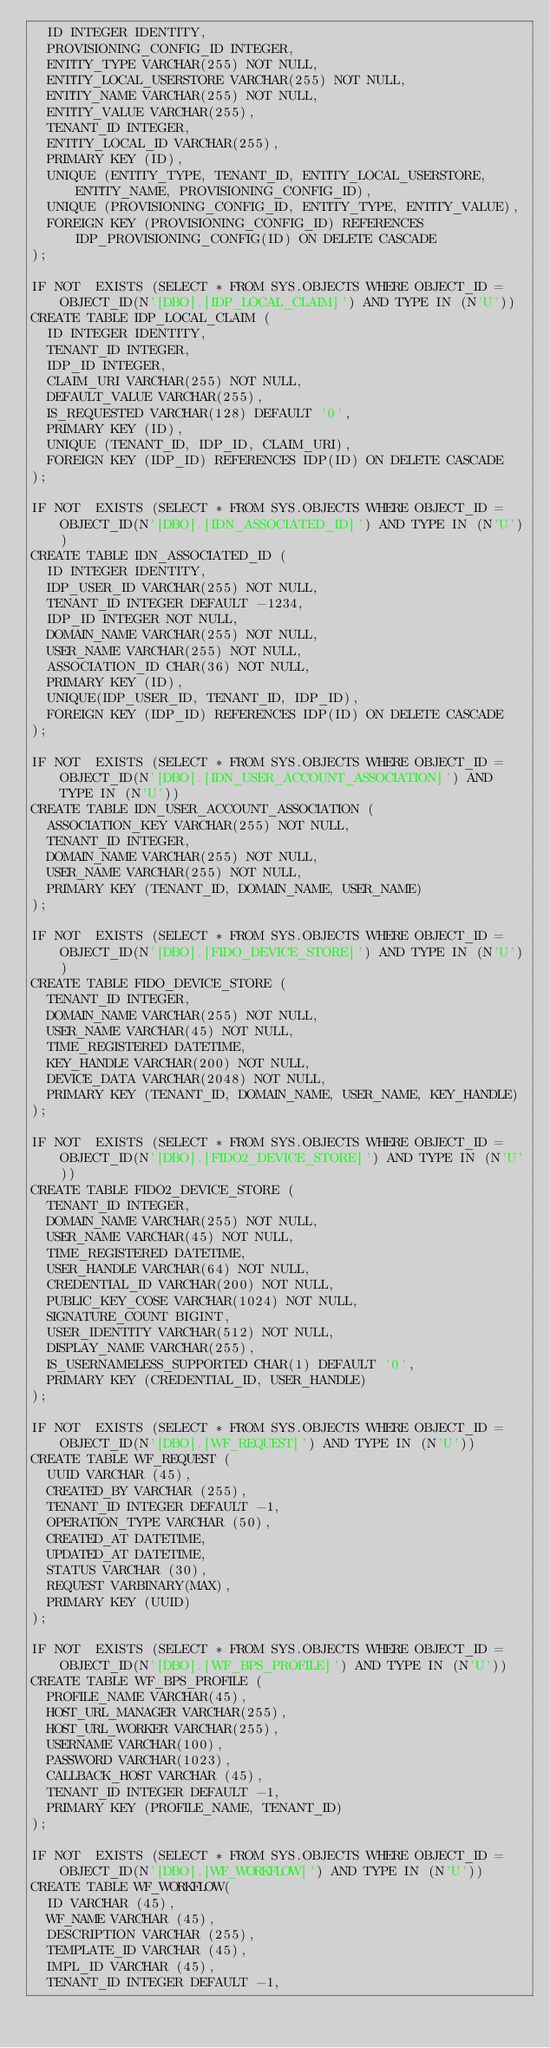Convert code to text. <code><loc_0><loc_0><loc_500><loc_500><_SQL_>  ID INTEGER IDENTITY,
  PROVISIONING_CONFIG_ID INTEGER,
  ENTITY_TYPE VARCHAR(255) NOT NULL,
  ENTITY_LOCAL_USERSTORE VARCHAR(255) NOT NULL,
  ENTITY_NAME VARCHAR(255) NOT NULL,
  ENTITY_VALUE VARCHAR(255),
  TENANT_ID INTEGER,
  ENTITY_LOCAL_ID VARCHAR(255),
  PRIMARY KEY (ID),
  UNIQUE (ENTITY_TYPE, TENANT_ID, ENTITY_LOCAL_USERSTORE, ENTITY_NAME, PROVISIONING_CONFIG_ID),
  UNIQUE (PROVISIONING_CONFIG_ID, ENTITY_TYPE, ENTITY_VALUE),
  FOREIGN KEY (PROVISIONING_CONFIG_ID) REFERENCES IDP_PROVISIONING_CONFIG(ID) ON DELETE CASCADE
);

IF NOT  EXISTS (SELECT * FROM SYS.OBJECTS WHERE OBJECT_ID = OBJECT_ID(N'[DBO].[IDP_LOCAL_CLAIM]') AND TYPE IN (N'U'))
CREATE TABLE IDP_LOCAL_CLAIM (
  ID INTEGER IDENTITY,
  TENANT_ID INTEGER,
  IDP_ID INTEGER,
  CLAIM_URI VARCHAR(255) NOT NULL,
  DEFAULT_VALUE VARCHAR(255),
  IS_REQUESTED VARCHAR(128) DEFAULT '0',
  PRIMARY KEY (ID),
  UNIQUE (TENANT_ID, IDP_ID, CLAIM_URI),
  FOREIGN KEY (IDP_ID) REFERENCES IDP(ID) ON DELETE CASCADE
);

IF NOT  EXISTS (SELECT * FROM SYS.OBJECTS WHERE OBJECT_ID = OBJECT_ID(N'[DBO].[IDN_ASSOCIATED_ID]') AND TYPE IN (N'U'))
CREATE TABLE IDN_ASSOCIATED_ID (
  ID INTEGER IDENTITY,
  IDP_USER_ID VARCHAR(255) NOT NULL,
  TENANT_ID INTEGER DEFAULT -1234,
  IDP_ID INTEGER NOT NULL,
  DOMAIN_NAME VARCHAR(255) NOT NULL,
  USER_NAME VARCHAR(255) NOT NULL,
  ASSOCIATION_ID CHAR(36) NOT NULL,
  PRIMARY KEY (ID),
  UNIQUE(IDP_USER_ID, TENANT_ID, IDP_ID),
  FOREIGN KEY (IDP_ID) REFERENCES IDP(ID) ON DELETE CASCADE
);

IF NOT  EXISTS (SELECT * FROM SYS.OBJECTS WHERE OBJECT_ID = OBJECT_ID(N'[DBO].[IDN_USER_ACCOUNT_ASSOCIATION]') AND TYPE IN (N'U'))
CREATE TABLE IDN_USER_ACCOUNT_ASSOCIATION (
  ASSOCIATION_KEY VARCHAR(255) NOT NULL,
  TENANT_ID INTEGER,
  DOMAIN_NAME VARCHAR(255) NOT NULL,
  USER_NAME VARCHAR(255) NOT NULL,
  PRIMARY KEY (TENANT_ID, DOMAIN_NAME, USER_NAME)
);

IF NOT  EXISTS (SELECT * FROM SYS.OBJECTS WHERE OBJECT_ID = OBJECT_ID(N'[DBO].[FIDO_DEVICE_STORE]') AND TYPE IN (N'U'))
CREATE TABLE FIDO_DEVICE_STORE (
  TENANT_ID INTEGER,
  DOMAIN_NAME VARCHAR(255) NOT NULL,
  USER_NAME VARCHAR(45) NOT NULL,
  TIME_REGISTERED DATETIME,
  KEY_HANDLE VARCHAR(200) NOT NULL,
  DEVICE_DATA VARCHAR(2048) NOT NULL,
  PRIMARY KEY (TENANT_ID, DOMAIN_NAME, USER_NAME, KEY_HANDLE)
);

IF NOT  EXISTS (SELECT * FROM SYS.OBJECTS WHERE OBJECT_ID = OBJECT_ID(N'[DBO].[FIDO2_DEVICE_STORE]') AND TYPE IN (N'U'))
CREATE TABLE FIDO2_DEVICE_STORE (
  TENANT_ID INTEGER,
  DOMAIN_NAME VARCHAR(255) NOT NULL,
  USER_NAME VARCHAR(45) NOT NULL,
  TIME_REGISTERED DATETIME,
  USER_HANDLE VARCHAR(64) NOT NULL,
  CREDENTIAL_ID VARCHAR(200) NOT NULL,
  PUBLIC_KEY_COSE VARCHAR(1024) NOT NULL,
  SIGNATURE_COUNT BIGINT,
  USER_IDENTITY VARCHAR(512) NOT NULL,
  DISPLAY_NAME VARCHAR(255),
  IS_USERNAMELESS_SUPPORTED CHAR(1) DEFAULT '0',
  PRIMARY KEY (CREDENTIAL_ID, USER_HANDLE)
);

IF NOT  EXISTS (SELECT * FROM SYS.OBJECTS WHERE OBJECT_ID = OBJECT_ID(N'[DBO].[WF_REQUEST]') AND TYPE IN (N'U'))
CREATE TABLE WF_REQUEST (
  UUID VARCHAR (45),
  CREATED_BY VARCHAR (255),
  TENANT_ID INTEGER DEFAULT -1,
  OPERATION_TYPE VARCHAR (50),
  CREATED_AT DATETIME,
  UPDATED_AT DATETIME,
  STATUS VARCHAR (30),
  REQUEST VARBINARY(MAX),
  PRIMARY KEY (UUID)
);

IF NOT  EXISTS (SELECT * FROM SYS.OBJECTS WHERE OBJECT_ID = OBJECT_ID(N'[DBO].[WF_BPS_PROFILE]') AND TYPE IN (N'U'))
CREATE TABLE WF_BPS_PROFILE (
  PROFILE_NAME VARCHAR(45),
  HOST_URL_MANAGER VARCHAR(255),
  HOST_URL_WORKER VARCHAR(255),
  USERNAME VARCHAR(100),
  PASSWORD VARCHAR(1023),
  CALLBACK_HOST VARCHAR (45),
  TENANT_ID INTEGER DEFAULT -1,
  PRIMARY KEY (PROFILE_NAME, TENANT_ID)
);

IF NOT  EXISTS (SELECT * FROM SYS.OBJECTS WHERE OBJECT_ID = OBJECT_ID(N'[DBO].[WF_WORKFLOW]') AND TYPE IN (N'U'))
CREATE TABLE WF_WORKFLOW(
  ID VARCHAR (45),
  WF_NAME VARCHAR (45),
  DESCRIPTION VARCHAR (255),
  TEMPLATE_ID VARCHAR (45),
  IMPL_ID VARCHAR (45),
  TENANT_ID INTEGER DEFAULT -1,</code> 